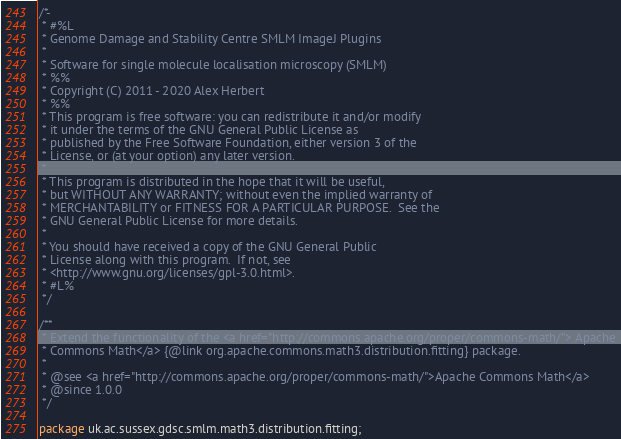<code> <loc_0><loc_0><loc_500><loc_500><_Java_>/*-
 * #%L
 * Genome Damage and Stability Centre SMLM ImageJ Plugins
 *
 * Software for single molecule localisation microscopy (SMLM)
 * %%
 * Copyright (C) 2011 - 2020 Alex Herbert
 * %%
 * This program is free software: you can redistribute it and/or modify
 * it under the terms of the GNU General Public License as
 * published by the Free Software Foundation, either version 3 of the
 * License, or (at your option) any later version.
 *
 * This program is distributed in the hope that it will be useful,
 * but WITHOUT ANY WARRANTY; without even the implied warranty of
 * MERCHANTABILITY or FITNESS FOR A PARTICULAR PURPOSE.  See the
 * GNU General Public License for more details.
 *
 * You should have received a copy of the GNU General Public
 * License along with this program.  If not, see
 * <http://www.gnu.org/licenses/gpl-3.0.html>.
 * #L%
 */

/**
 * Extend the functionality of the <a href="http://commons.apache.org/proper/commons-math/"> Apache
 * Commons Math</a> {@link org.apache.commons.math3.distribution.fitting} package.
 *
 * @see <a href="http://commons.apache.org/proper/commons-math/">Apache Commons Math</a>
 * @since 1.0.0
 */

package uk.ac.sussex.gdsc.smlm.math3.distribution.fitting;
</code> 